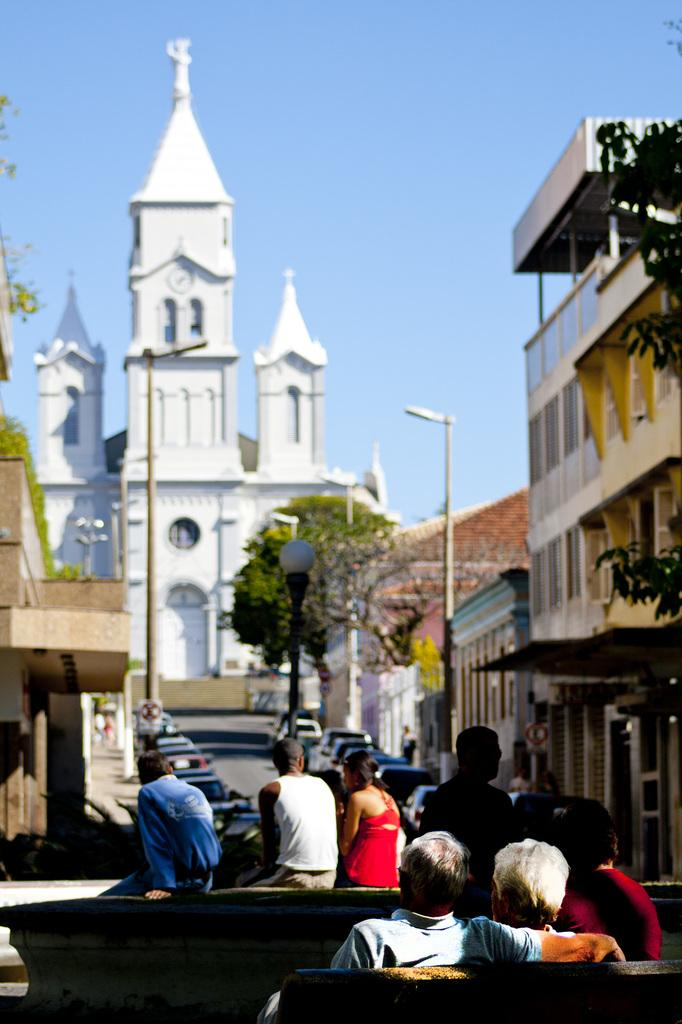What type of structures can be seen in the image? There are buildings with windows in the image. What objects are present in the image that are used for support or signage? There are poles in the image. What can be seen illuminating the scene in the image? There are lights in the image. What type of transportation is visible in the image? There are vehicles in the image. Are there any people visible in the vehicles? Yes, there are people in vehicles in the image. What type of natural elements can be seen in the image? There are trees in the image. What part of the environment is visible in the image? The sky is visible in the image. What type of bath can be seen in the image? There is no bath present in the image. Who is the creator of the vehicles in the image? The creator of the vehicles is not visible or identifiable in the image. 